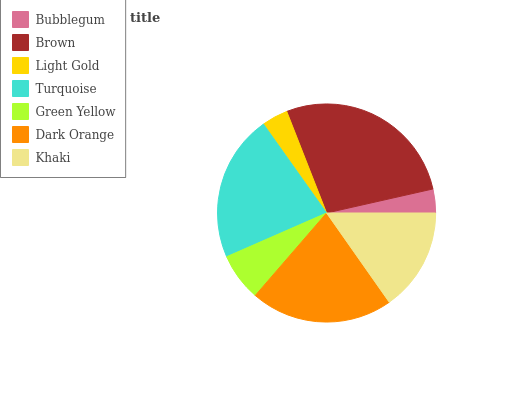Is Bubblegum the minimum?
Answer yes or no. Yes. Is Brown the maximum?
Answer yes or no. Yes. Is Light Gold the minimum?
Answer yes or no. No. Is Light Gold the maximum?
Answer yes or no. No. Is Brown greater than Light Gold?
Answer yes or no. Yes. Is Light Gold less than Brown?
Answer yes or no. Yes. Is Light Gold greater than Brown?
Answer yes or no. No. Is Brown less than Light Gold?
Answer yes or no. No. Is Khaki the high median?
Answer yes or no. Yes. Is Khaki the low median?
Answer yes or no. Yes. Is Light Gold the high median?
Answer yes or no. No. Is Light Gold the low median?
Answer yes or no. No. 